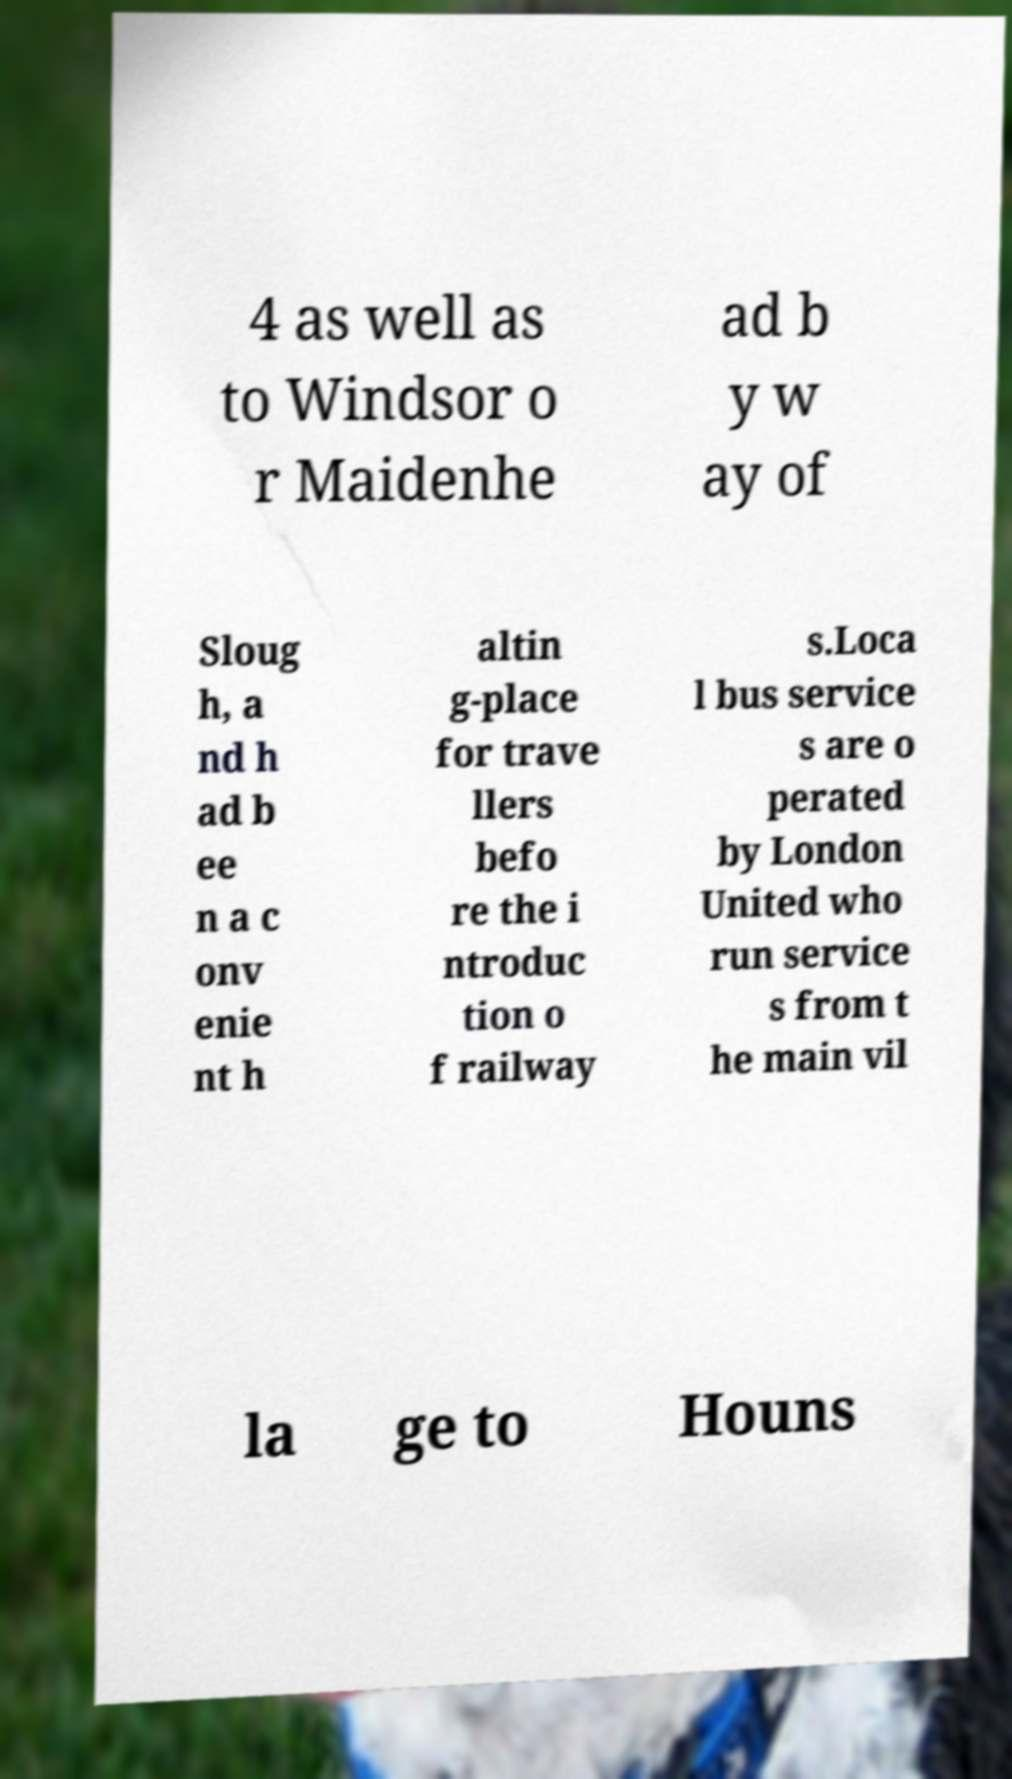Please read and relay the text visible in this image. What does it say? 4 as well as to Windsor o r Maidenhe ad b y w ay of Sloug h, a nd h ad b ee n a c onv enie nt h altin g-place for trave llers befo re the i ntroduc tion o f railway s.Loca l bus service s are o perated by London United who run service s from t he main vil la ge to Houns 